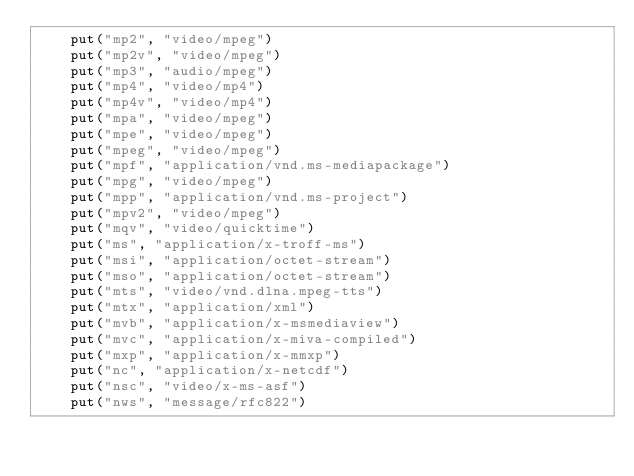Convert code to text. <code><loc_0><loc_0><loc_500><loc_500><_Kotlin_>    put("mp2", "video/mpeg")
    put("mp2v", "video/mpeg")
    put("mp3", "audio/mpeg")
    put("mp4", "video/mp4")
    put("mp4v", "video/mp4")
    put("mpa", "video/mpeg")
    put("mpe", "video/mpeg")
    put("mpeg", "video/mpeg")
    put("mpf", "application/vnd.ms-mediapackage")
    put("mpg", "video/mpeg")
    put("mpp", "application/vnd.ms-project")
    put("mpv2", "video/mpeg")
    put("mqv", "video/quicktime")
    put("ms", "application/x-troff-ms")
    put("msi", "application/octet-stream")
    put("mso", "application/octet-stream")
    put("mts", "video/vnd.dlna.mpeg-tts")
    put("mtx", "application/xml")
    put("mvb", "application/x-msmediaview")
    put("mvc", "application/x-miva-compiled")
    put("mxp", "application/x-mmxp")
    put("nc", "application/x-netcdf")
    put("nsc", "video/x-ms-asf")
    put("nws", "message/rfc822")</code> 